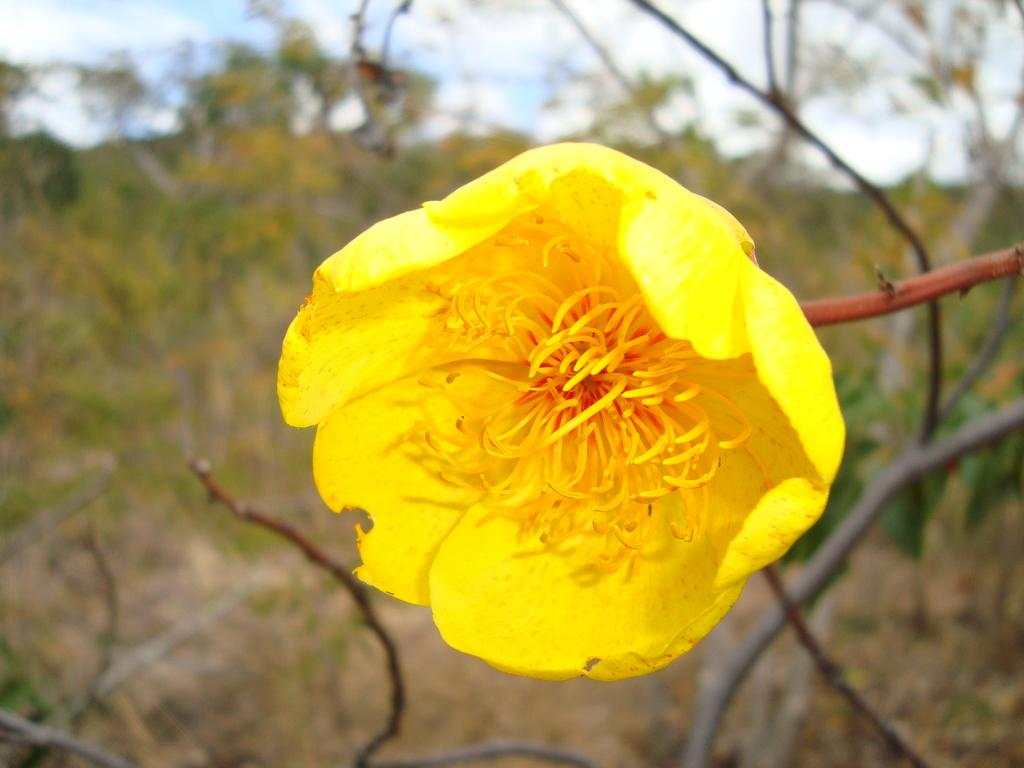What type of flower can be seen in the image? There is a yellow flower in the image. What other natural elements are present in the image? There are trees in the image. What can be seen in the background of the image? The sky is visible in the background of the image. What type of metal or steel is visible in the image? There is no metal or steel present in the image; it features a yellow flower, trees, and the sky. 